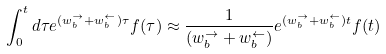<formula> <loc_0><loc_0><loc_500><loc_500>\int _ { 0 } ^ { t } d \tau e ^ { ( w _ { b } ^ { \rightarrow } + w _ { b } ^ { \leftarrow } ) \tau } f ( \tau ) \approx \frac { 1 } { ( w _ { b } ^ { \rightarrow } + w _ { b } ^ { \leftarrow } ) } e ^ { ( w _ { b } ^ { \rightarrow } + w _ { b } ^ { \leftarrow } ) t } f ( t )</formula> 